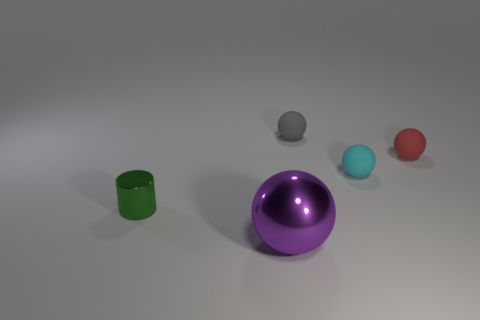What number of objects are either small balls that are in front of the tiny gray sphere or balls that are on the right side of the large metallic thing?
Offer a terse response. 3. The tiny gray thing is what shape?
Ensure brevity in your answer.  Sphere. How many other objects are there of the same material as the red thing?
Give a very brief answer. 2. The gray matte object that is the same shape as the tiny cyan thing is what size?
Give a very brief answer. Small. What is the material of the thing on the left side of the metallic thing that is in front of the tiny object that is to the left of the large purple thing?
Offer a very short reply. Metal. Is there a big cyan metallic sphere?
Provide a short and direct response. No. Does the large shiny ball have the same color as the tiny object left of the tiny gray rubber ball?
Your response must be concise. No. What is the color of the big object?
Your answer should be very brief. Purple. Is there anything else that is the same shape as the tiny red thing?
Give a very brief answer. Yes. The other large metal thing that is the same shape as the red thing is what color?
Offer a terse response. Purple. 